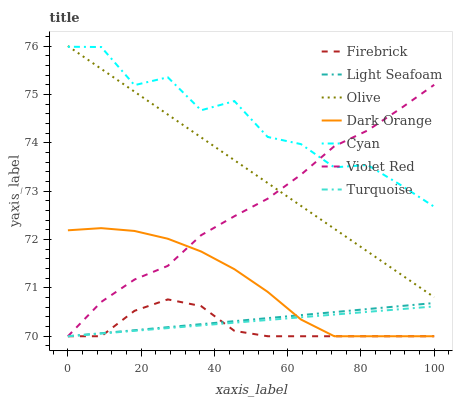Does Firebrick have the minimum area under the curve?
Answer yes or no. Yes. Does Cyan have the maximum area under the curve?
Answer yes or no. Yes. Does Violet Red have the minimum area under the curve?
Answer yes or no. No. Does Violet Red have the maximum area under the curve?
Answer yes or no. No. Is Olive the smoothest?
Answer yes or no. Yes. Is Cyan the roughest?
Answer yes or no. Yes. Is Violet Red the smoothest?
Answer yes or no. No. Is Violet Red the roughest?
Answer yes or no. No. Does Dark Orange have the lowest value?
Answer yes or no. Yes. Does Olive have the lowest value?
Answer yes or no. No. Does Olive have the highest value?
Answer yes or no. Yes. Does Violet Red have the highest value?
Answer yes or no. No. Is Light Seafoam less than Olive?
Answer yes or no. Yes. Is Olive greater than Firebrick?
Answer yes or no. Yes. Does Turquoise intersect Light Seafoam?
Answer yes or no. Yes. Is Turquoise less than Light Seafoam?
Answer yes or no. No. Is Turquoise greater than Light Seafoam?
Answer yes or no. No. Does Light Seafoam intersect Olive?
Answer yes or no. No. 